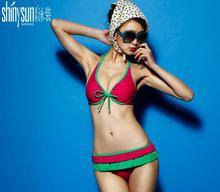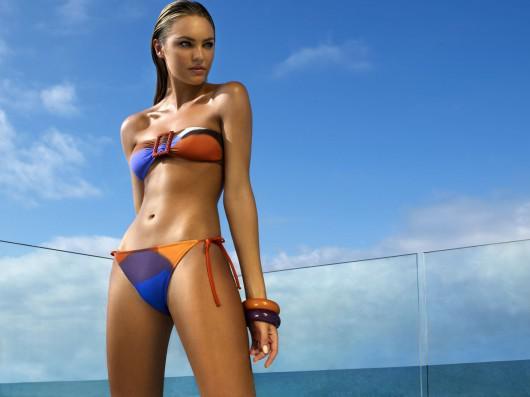The first image is the image on the left, the second image is the image on the right. Examine the images to the left and right. Is the description "There is a female wearing a pink bikini in the right image." accurate? Answer yes or no. No. The first image is the image on the left, the second image is the image on the right. Analyze the images presented: Is the assertion "One of the images shows exactly one woman sitting at the beach wearing a bikini." valid? Answer yes or no. No. 